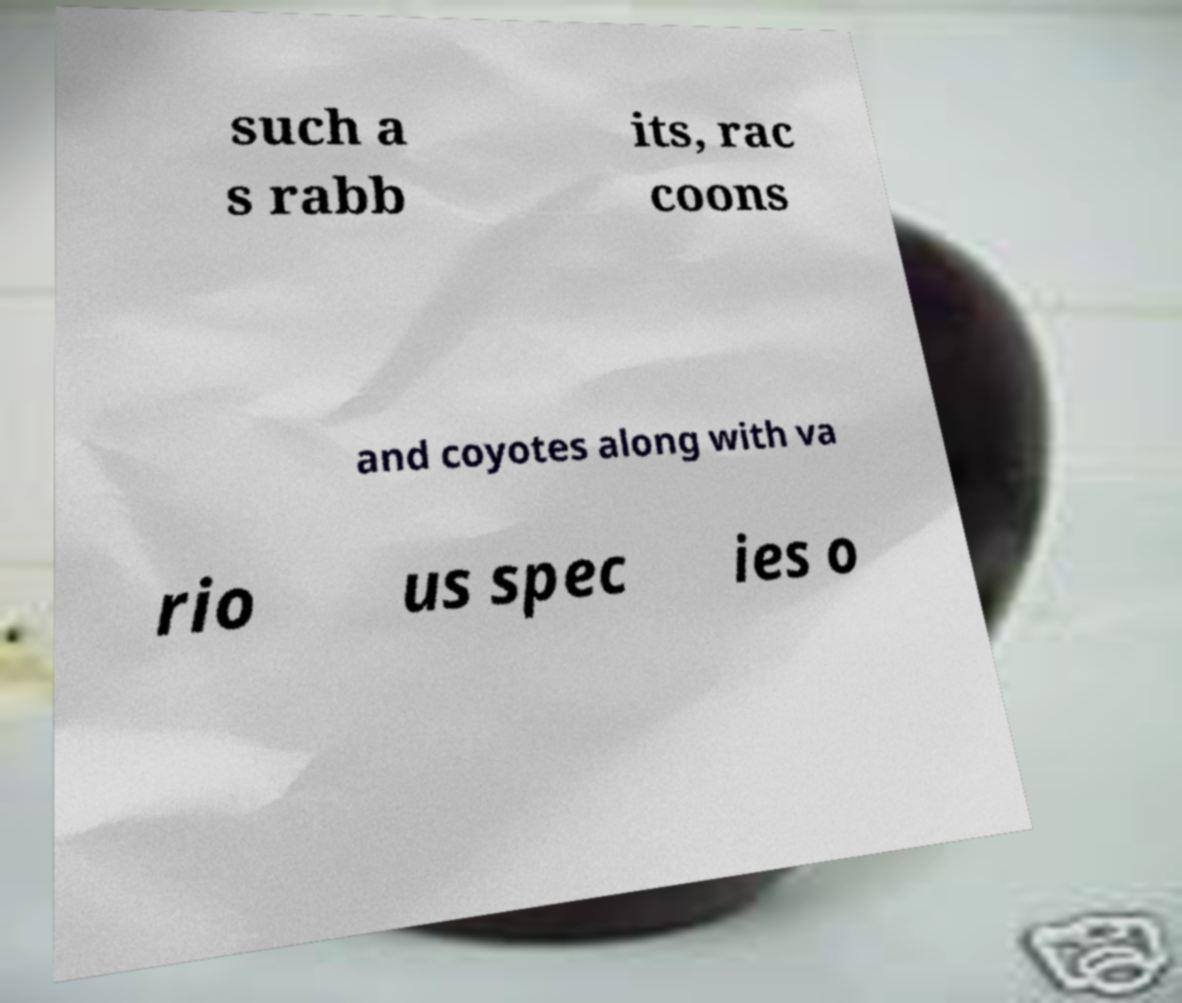There's text embedded in this image that I need extracted. Can you transcribe it verbatim? such a s rabb its, rac coons and coyotes along with va rio us spec ies o 